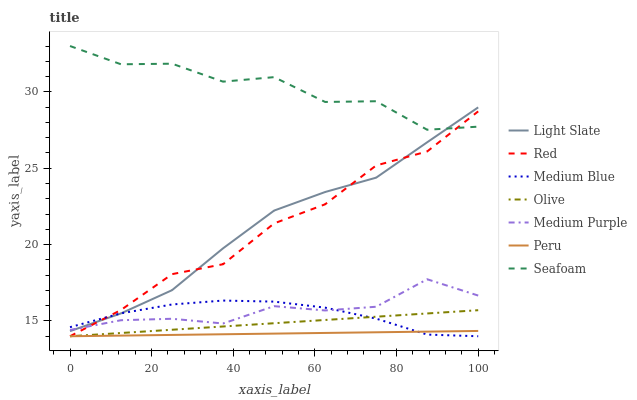Does Peru have the minimum area under the curve?
Answer yes or no. Yes. Does Seafoam have the maximum area under the curve?
Answer yes or no. Yes. Does Medium Blue have the minimum area under the curve?
Answer yes or no. No. Does Medium Blue have the maximum area under the curve?
Answer yes or no. No. Is Peru the smoothest?
Answer yes or no. Yes. Is Seafoam the roughest?
Answer yes or no. Yes. Is Medium Blue the smoothest?
Answer yes or no. No. Is Medium Blue the roughest?
Answer yes or no. No. Does Medium Blue have the lowest value?
Answer yes or no. Yes. Does Seafoam have the lowest value?
Answer yes or no. No. Does Seafoam have the highest value?
Answer yes or no. Yes. Does Medium Blue have the highest value?
Answer yes or no. No. Is Peru less than Light Slate?
Answer yes or no. Yes. Is Seafoam greater than Medium Purple?
Answer yes or no. Yes. Does Peru intersect Red?
Answer yes or no. Yes. Is Peru less than Red?
Answer yes or no. No. Is Peru greater than Red?
Answer yes or no. No. Does Peru intersect Light Slate?
Answer yes or no. No. 